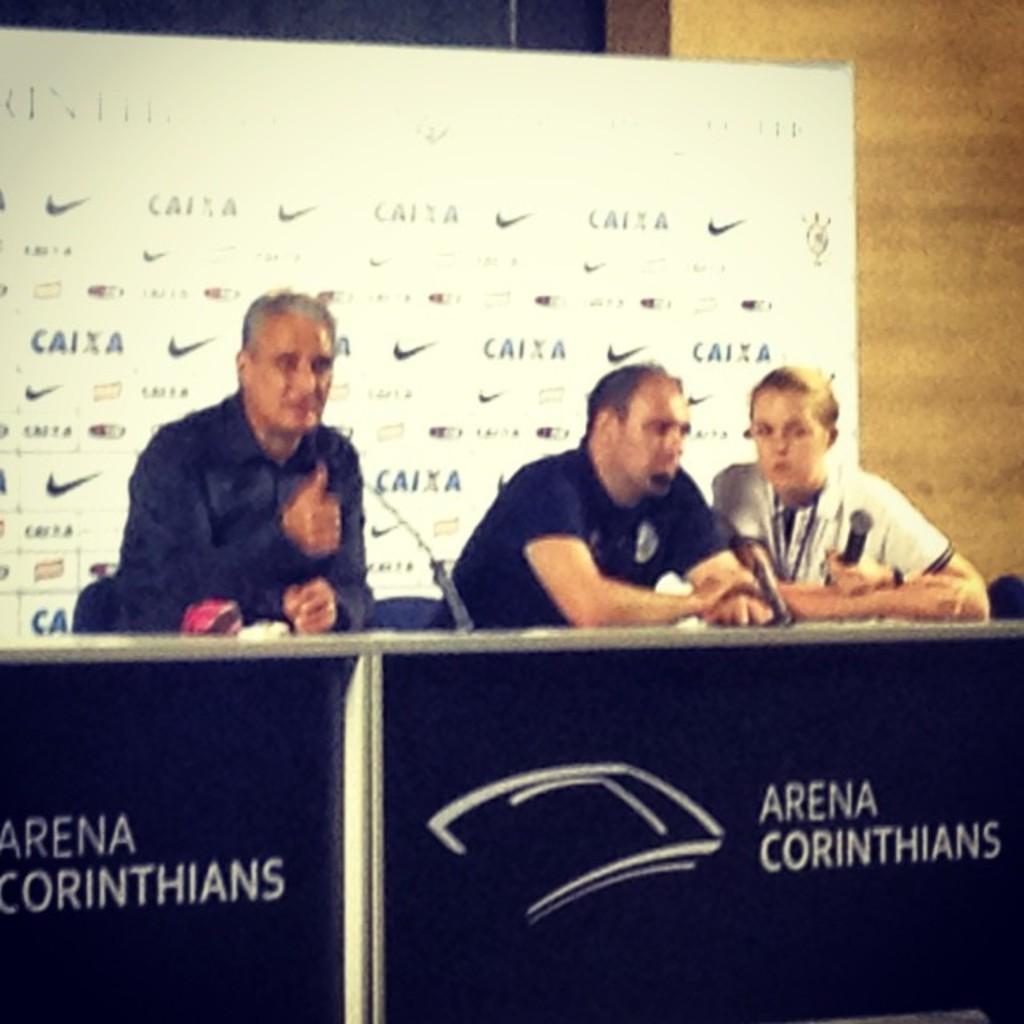In one or two sentences, can you explain what this image depicts? The picture is taken during a conference. In the center of the picture there are tables, mics and people. In the background there are banner, wall and curtain. 